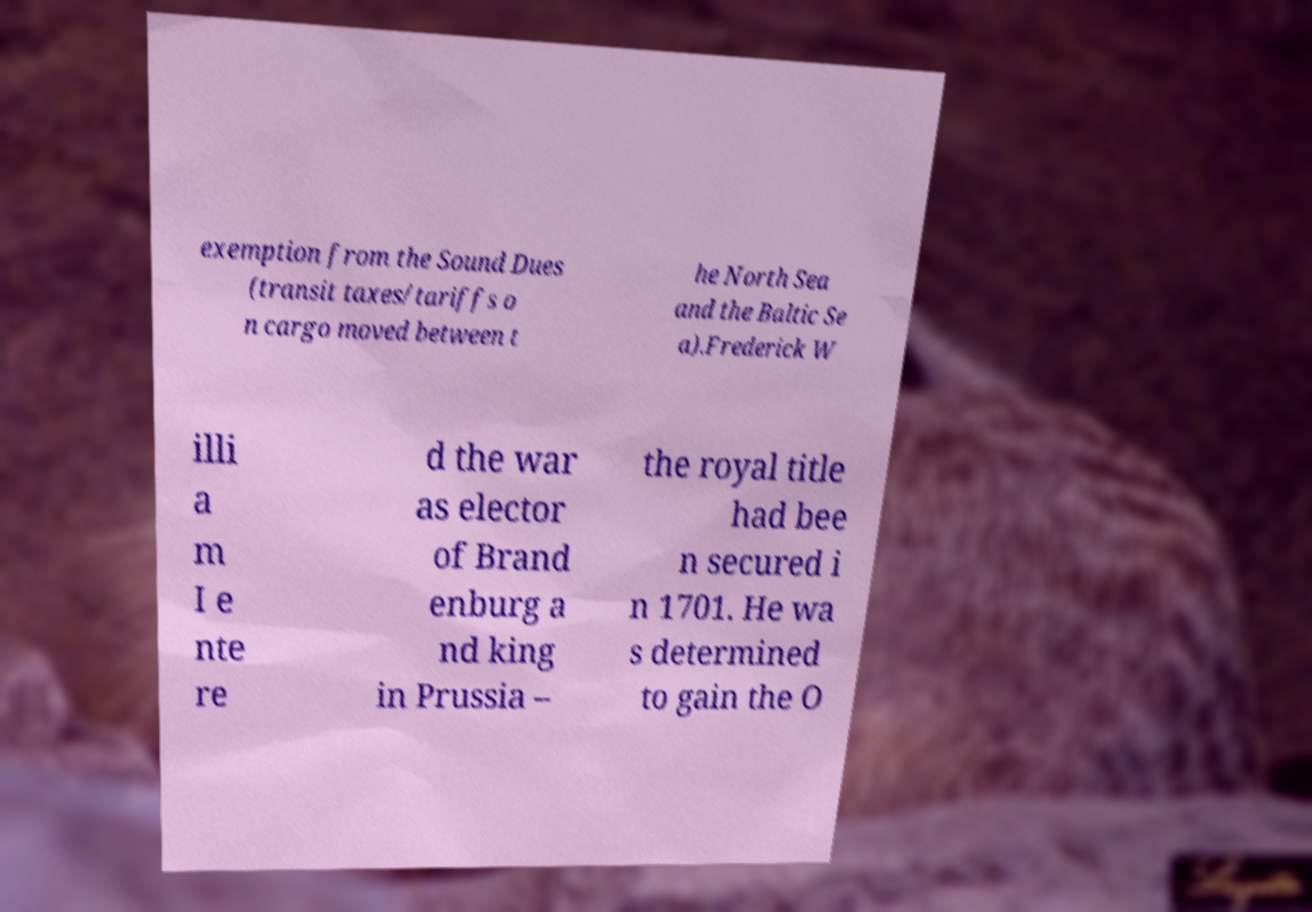Can you read and provide the text displayed in the image?This photo seems to have some interesting text. Can you extract and type it out for me? exemption from the Sound Dues (transit taxes/tariffs o n cargo moved between t he North Sea and the Baltic Se a).Frederick W illi a m I e nte re d the war as elector of Brand enburg a nd king in Prussia – the royal title had bee n secured i n 1701. He wa s determined to gain the O 